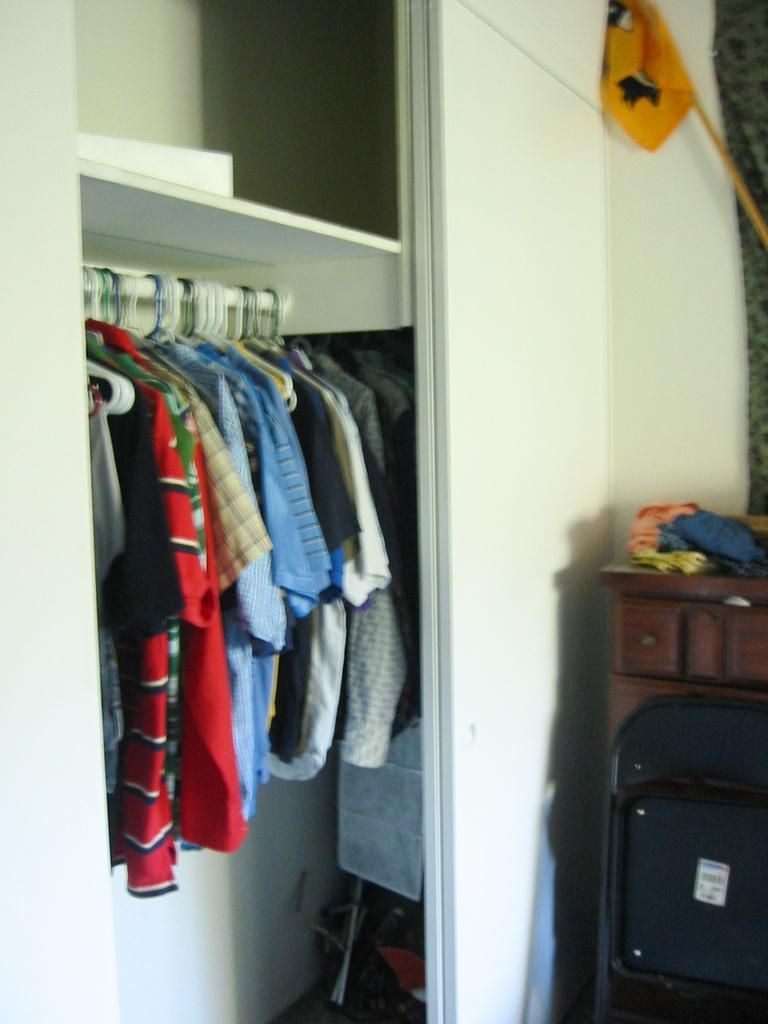What type of furniture is present in the image? There is a cupboard, a table, and a chair in the image. What is stored inside the cupboard? The cupboard contains dresses. What is on top of the table? The table has clothes on it. What statement needs to be made by the chair in the image? There is no need for the chair to make a statement in the image, as it is an inanimate object. 